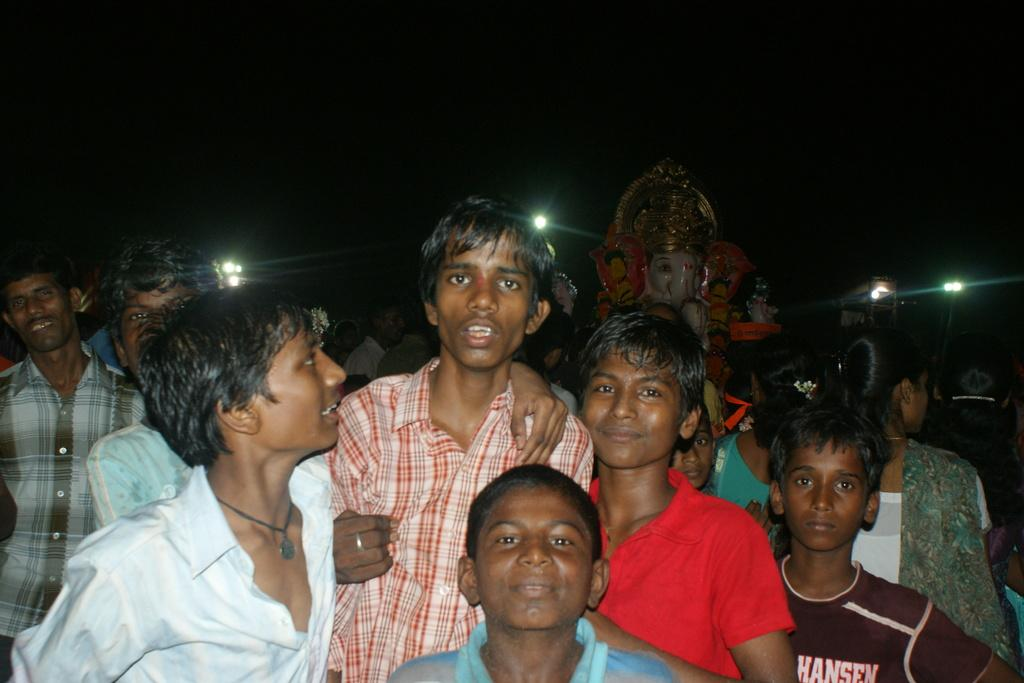What is the main subject of the image? The main subject of the image is a group of people. Are there any other objects or structures in the image? Yes, there is a statue in the image. What can be seen in the image that provides illumination? There are lights in the image. How would you describe the overall lighting in the image? The background of the image is dark. What type of wren can be seen perched on the statue in the image? There is no wren present in the image; it only features a group of people, a statue, and lights. What book is the person reading in the image? There is no person reading a book in the image; the focus is on the group of people, the statue, and the lights. 